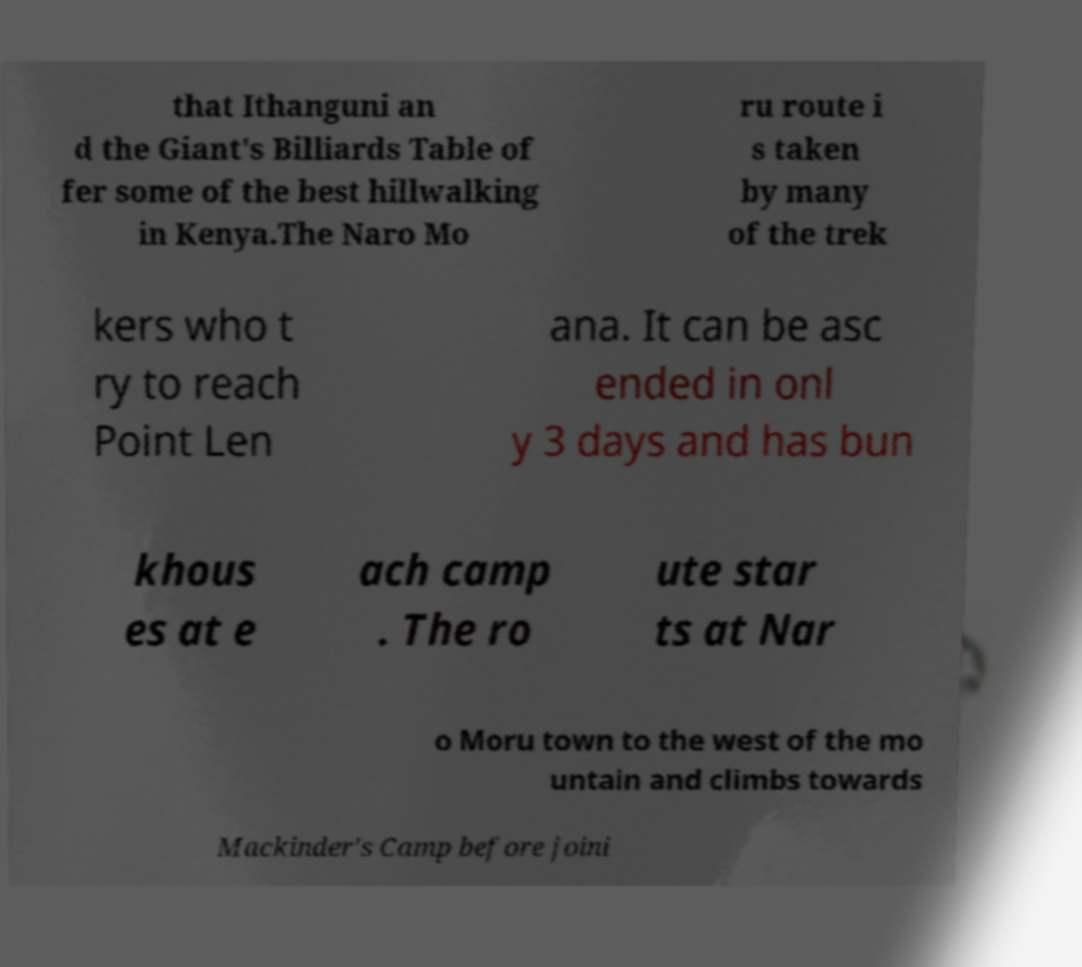There's text embedded in this image that I need extracted. Can you transcribe it verbatim? that Ithanguni an d the Giant's Billiards Table of fer some of the best hillwalking in Kenya.The Naro Mo ru route i s taken by many of the trek kers who t ry to reach Point Len ana. It can be asc ended in onl y 3 days and has bun khous es at e ach camp . The ro ute star ts at Nar o Moru town to the west of the mo untain and climbs towards Mackinder's Camp before joini 